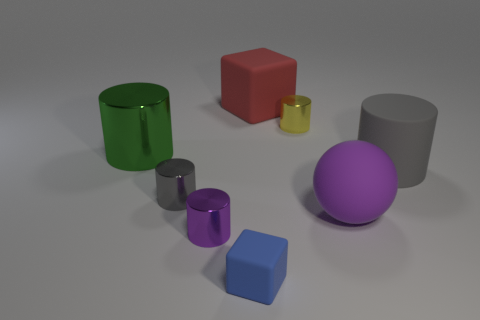How many cubes are tiny yellow things or large purple matte things?
Offer a terse response. 0. Is there a yellow shiny object?
Provide a short and direct response. Yes. What size is the yellow shiny object that is the same shape as the gray rubber object?
Your response must be concise. Small. There is a small shiny thing that is behind the large gray matte cylinder that is in front of the green cylinder; what shape is it?
Your response must be concise. Cylinder. What number of green things are either metallic cylinders or big shiny things?
Offer a very short reply. 1. The large metallic cylinder has what color?
Your response must be concise. Green. Does the gray matte cylinder have the same size as the green thing?
Offer a very short reply. Yes. Is there any other thing that has the same shape as the purple matte object?
Your answer should be compact. No. Is the material of the big purple sphere the same as the cube that is in front of the large green shiny cylinder?
Offer a terse response. Yes. There is a tiny cylinder in front of the small gray metallic cylinder; does it have the same color as the rubber ball?
Make the answer very short. Yes. 